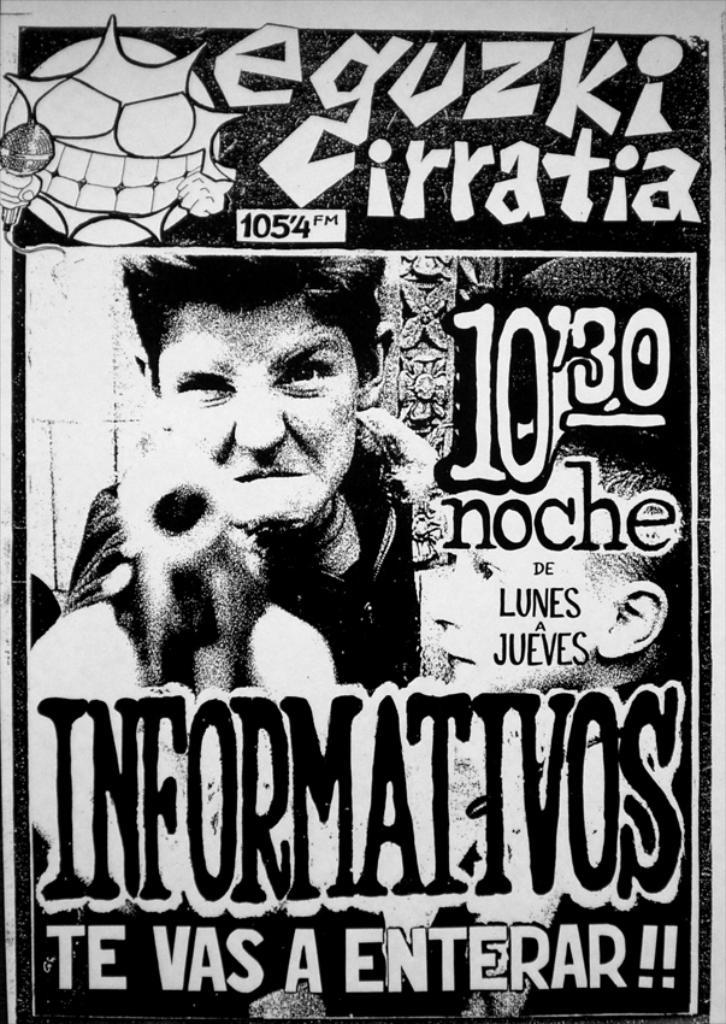<image>
Provide a brief description of the given image. A poster for eguzki cirratia is printed in black and white. 